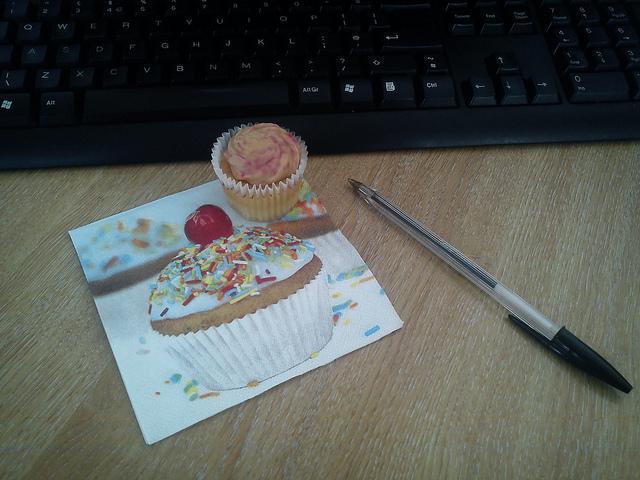How many real cupcakes are in the photo?
Give a very brief answer. 1. How many cakes can be seen?
Give a very brief answer. 2. 